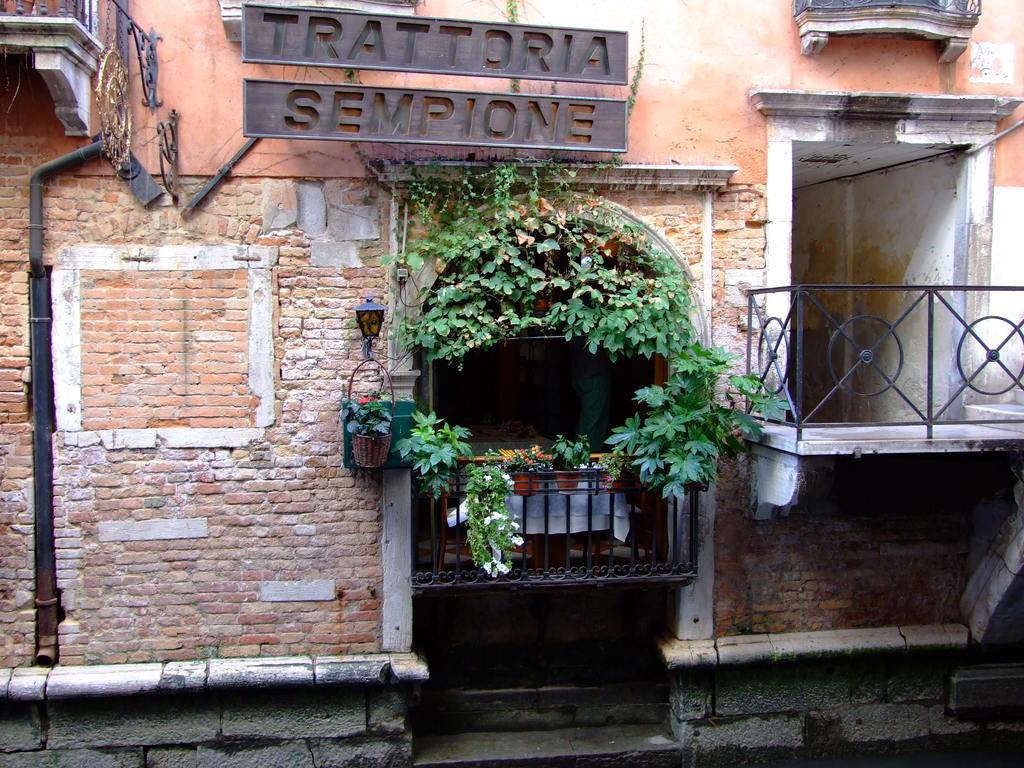Could you give a brief overview of what you see in this image? In this image there is a wall, there is a metal railing on the left and right corner. We can see potted plants, flowers, metal railing and text. 